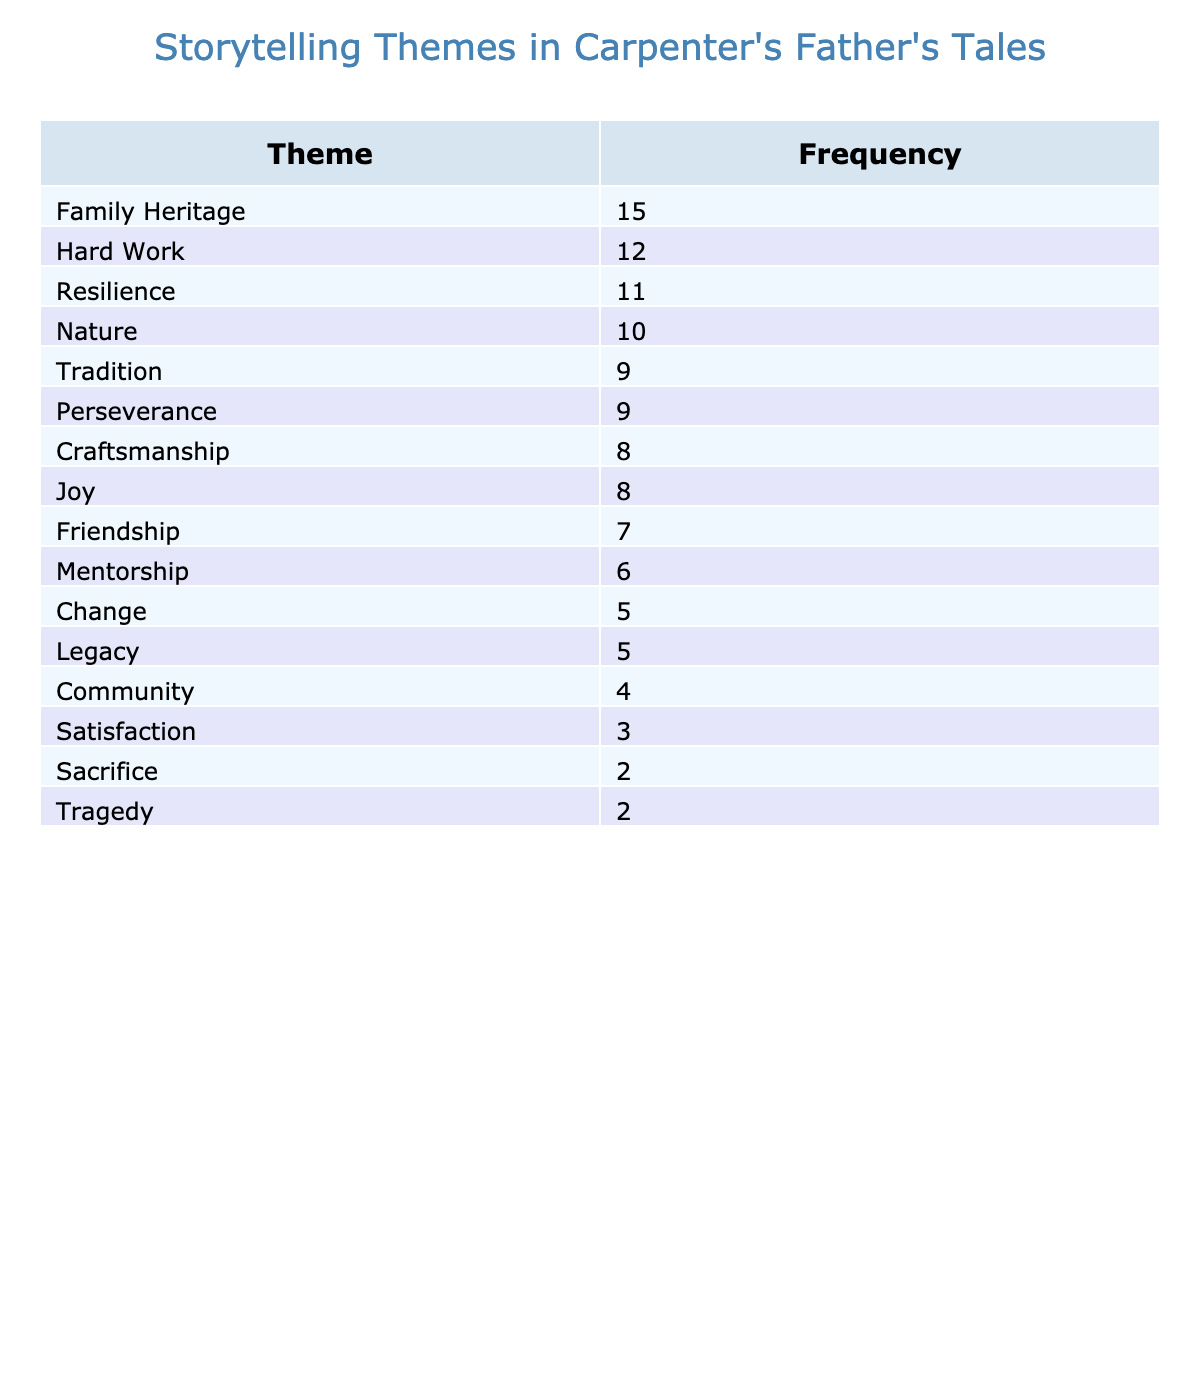What is the most common storytelling theme in the carpenter's father's tales? The table shows that the theme with the highest frequency is "Family Heritage," which has a frequency of 15.
Answer: Family Heritage Which theme is mentioned the least in the tales? According to the table, the themes "Satisfaction," "Sacrifice," and "Tragedy" all have the lowest frequency, which is 2.
Answer: Satisfaction, Sacrifice, Tragedy What is the total frequency of themes related to resilience and perseverance? To calculate this, we add the frequencies of "Resilience" (11) and "Perseverance" (9). The sum is 11 + 9 = 20.
Answer: 20 Are there more themes related to positive experiences or negative experiences? Positive experiences include "Joy," "Friendship," and "Family Heritage," with a total of 30. Negative experiences include "Tragedy," "Sacrifice," and "Satisfaction," totaling 7. Thus, there are more themes related to positive experiences.
Answer: Yes What is the average frequency of the storytelling themes? The total frequency is 12 + 9 + 15 + 8 + 10 + 7 + 11 + 5 + 6 + 4 + 3 + 2 + 2 + 8 + 9 + 5 =  16 themes. This gives an average frequency of 8.67 after dividing by the number of themes.
Answer: 8.67 Which theme has a frequency closest to the average frequency? The average frequency is approximately 8.67. The themes "Joy" (8), "Craftsmanship" (8), and "Change" (5) are close to this value, with "Joy" and "Craftsmanship" being the closest.
Answer: Joy, Craftsmanship Is there a theme that has the same frequency as "Change"? The table shows that "Legacy" has the same frequency as "Change," both with a value of 5.
Answer: Yes What two themes together have a frequency of 20? "Hard Work" (12) and "Resilience" (11) add up to 23, while "Family Heritage" (15) and "Change" (5) equal 20. Thus, the themes "Family Heritage" and "Change" together total 20.
Answer: Family Heritage and Change Which theme is more common, "Community" or "Friendship"? By checking the frequencies in the table, "Friendship" has a frequency of 7, while "Community" has a frequency of 4. Thus, "Friendship" is more common.
Answer: Friendship What themes have a frequency of 9? The table lists two themes with a frequency of 9: "Tradition" and "Perseverance."
Answer: Tradition, Perseverance 